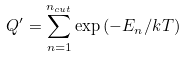Convert formula to latex. <formula><loc_0><loc_0><loc_500><loc_500>Q ^ { \prime } = \sum _ { n = 1 } ^ { n _ { c u t } } \exp { ( - E _ { n } / k T ) }</formula> 